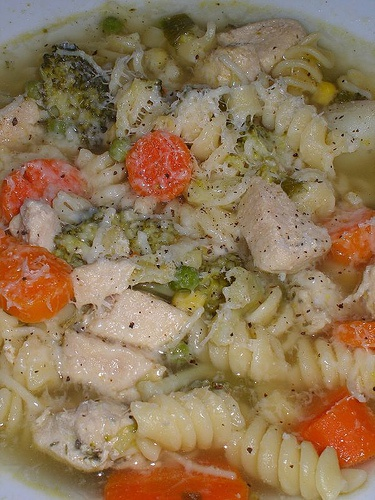Describe the objects in this image and their specific colors. I can see bowl in tan, olive, gray, and darkgray tones, broccoli in gray, darkgreen, and black tones, carrot in gray, brown, salmon, and red tones, carrot in gray, brown, salmon, and maroon tones, and carrot in gray, brown, and salmon tones in this image. 